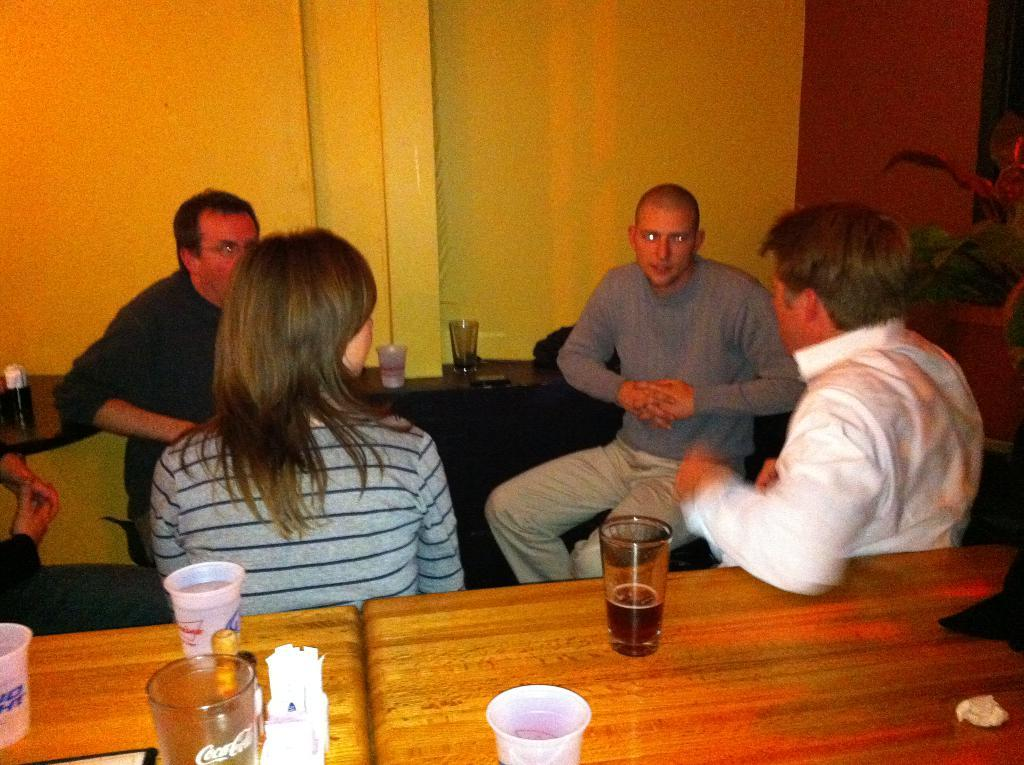What is happening in the image involving the group of people? The people in the image are sitting and talking to each other. What can be seen on the tables in the image? The tables have cups and other objects on them. How are the people arranged in the image? The people are sitting and talking to each other, suggesting they are seated around the tables. Can you tell me how many ants are crawling on the calculator in the image? There is no calculator or ants present in the image. What type of spot is visible on the table in the image? There is no spot visible on the table in the image. 